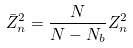Convert formula to latex. <formula><loc_0><loc_0><loc_500><loc_500>\bar { Z } ^ { 2 } _ { n } = \frac { N } { N - N _ { b } } Z ^ { 2 } _ { n }</formula> 